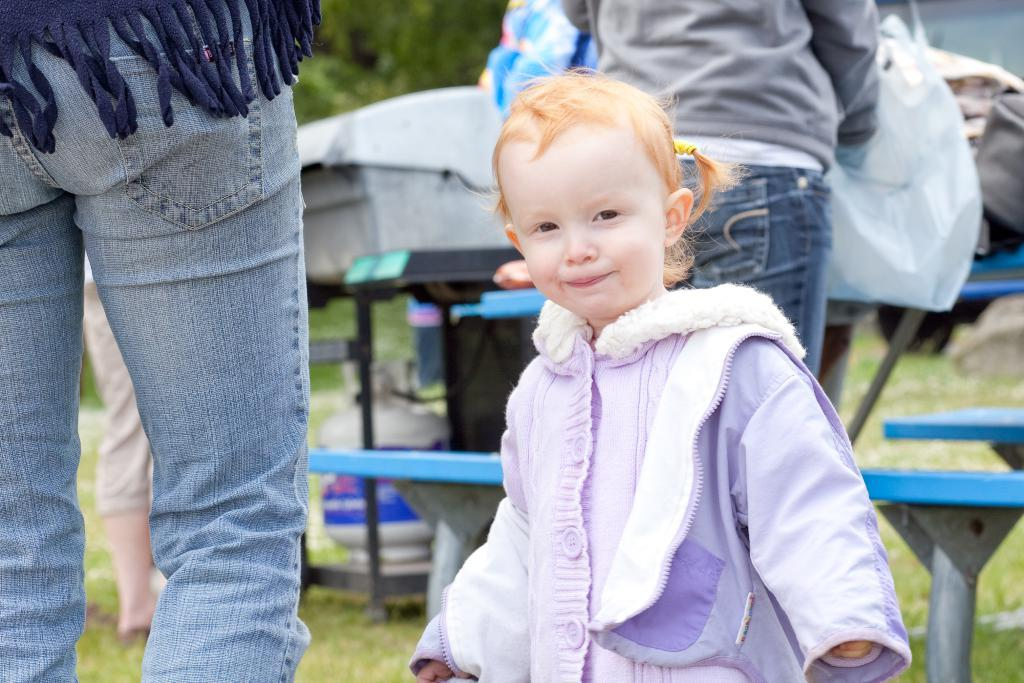What is the girl in the image doing? The girl is standing and smiling in the image. How many people are present in the image? There are three people standing in the image. What type of furniture is visible in the image? There are benches in the image. Is there any indication of a barbecue grill in the image? The speaker is not certain about the presence of a barbecue grill in the image. What type of bit is the girl taking in the image? There is no bit present in the image, as it refers to a small piece that is bitten off or a part that is used to control an animal. --- Facts: 1. There is a person in the image. 2. The person is wearing a hat. 3. The person is holding a book. 4. The background of the image is a park. Absurd Topics: robot Conversation: What is the main subject in the image? There is a person in the image. What is the person wearing in the image? The person is wearing a hat. What is the person holding in the image? The person is holding a book. What is the background of the image? The background of the image is a park. Reasoning: Let's think step by step in order to produce the conversation. We start by identifying the main subject of the image, which is the person. Next, we describe specific features of the person, such as the hat. Then, we observe the actions of the person, noting that they are holding a book. Finally, we describe the background of the image, which is a park. Absurd Question/Answer: What type of robot can be seen in the image? There is no robot present in the image. --- Facts: 1. There is a dog in the image. 2. The dog is sitting on a chair. 3. The dog is wearing a bow tie. 4. The background of the image is a living room. Absurd Topics: fish Conversation: What type of animal is in the image? There is a dog in the image. What is the dog doing in the image? The dog is sitting on a chair. What is the dog wearing in the image? The dog is wearing a bow tie. What is the background of the image? The background of the image is a living room. Reasoning: Let's think step by step in order to produce the conversation. We start by identifying the main subject of the image, which is the dog. Next, we describe specific features of the dog, such as the fact that it is sitting on a chair and wearing a bow tie. Then, we observe the actions of the dog, noting that they are sitting on a chair. Finally, we describe the background of the image, which is a living room. Abs 